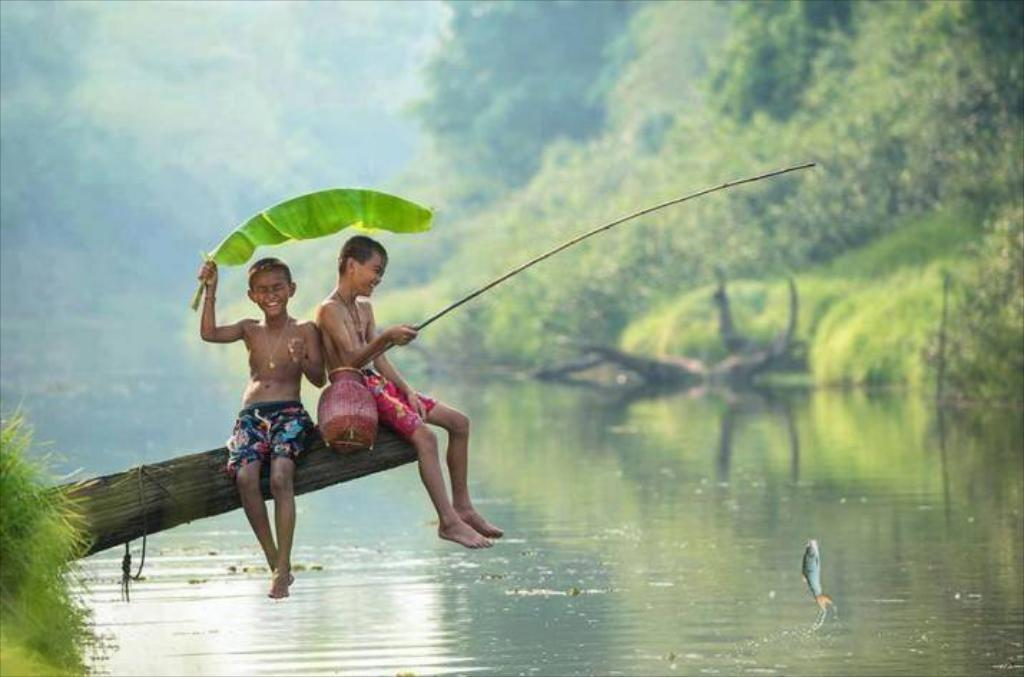How many boys are in the image? There are two boys in the image. What are the boys wearing? The boys are wearing colorful shorts. Where are the boys sitting? The boys are sitting on a tree trunk. What activity are the boys engaged in? The boys are catching fish with a rod. What can be seen in the background of the image? There is a blurred background in the image, and there are green trees in the background. What type of range is visible in the image? There is no range present in the image. What kind of vessel is being used by the boys to catch fish? The boys are using a fishing rod, not a vessel, to catch fish. 